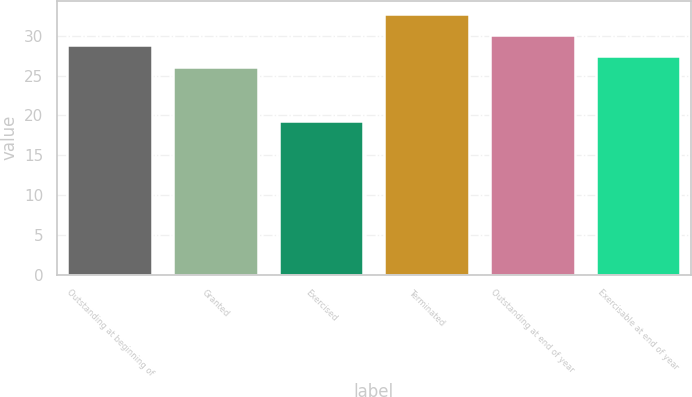Convert chart to OTSL. <chart><loc_0><loc_0><loc_500><loc_500><bar_chart><fcel>Outstanding at beginning of<fcel>Granted<fcel>Exercised<fcel>Terminated<fcel>Outstanding at end of year<fcel>Exercisable at end of year<nl><fcel>28.79<fcel>26.11<fcel>19.33<fcel>32.76<fcel>30.13<fcel>27.45<nl></chart> 